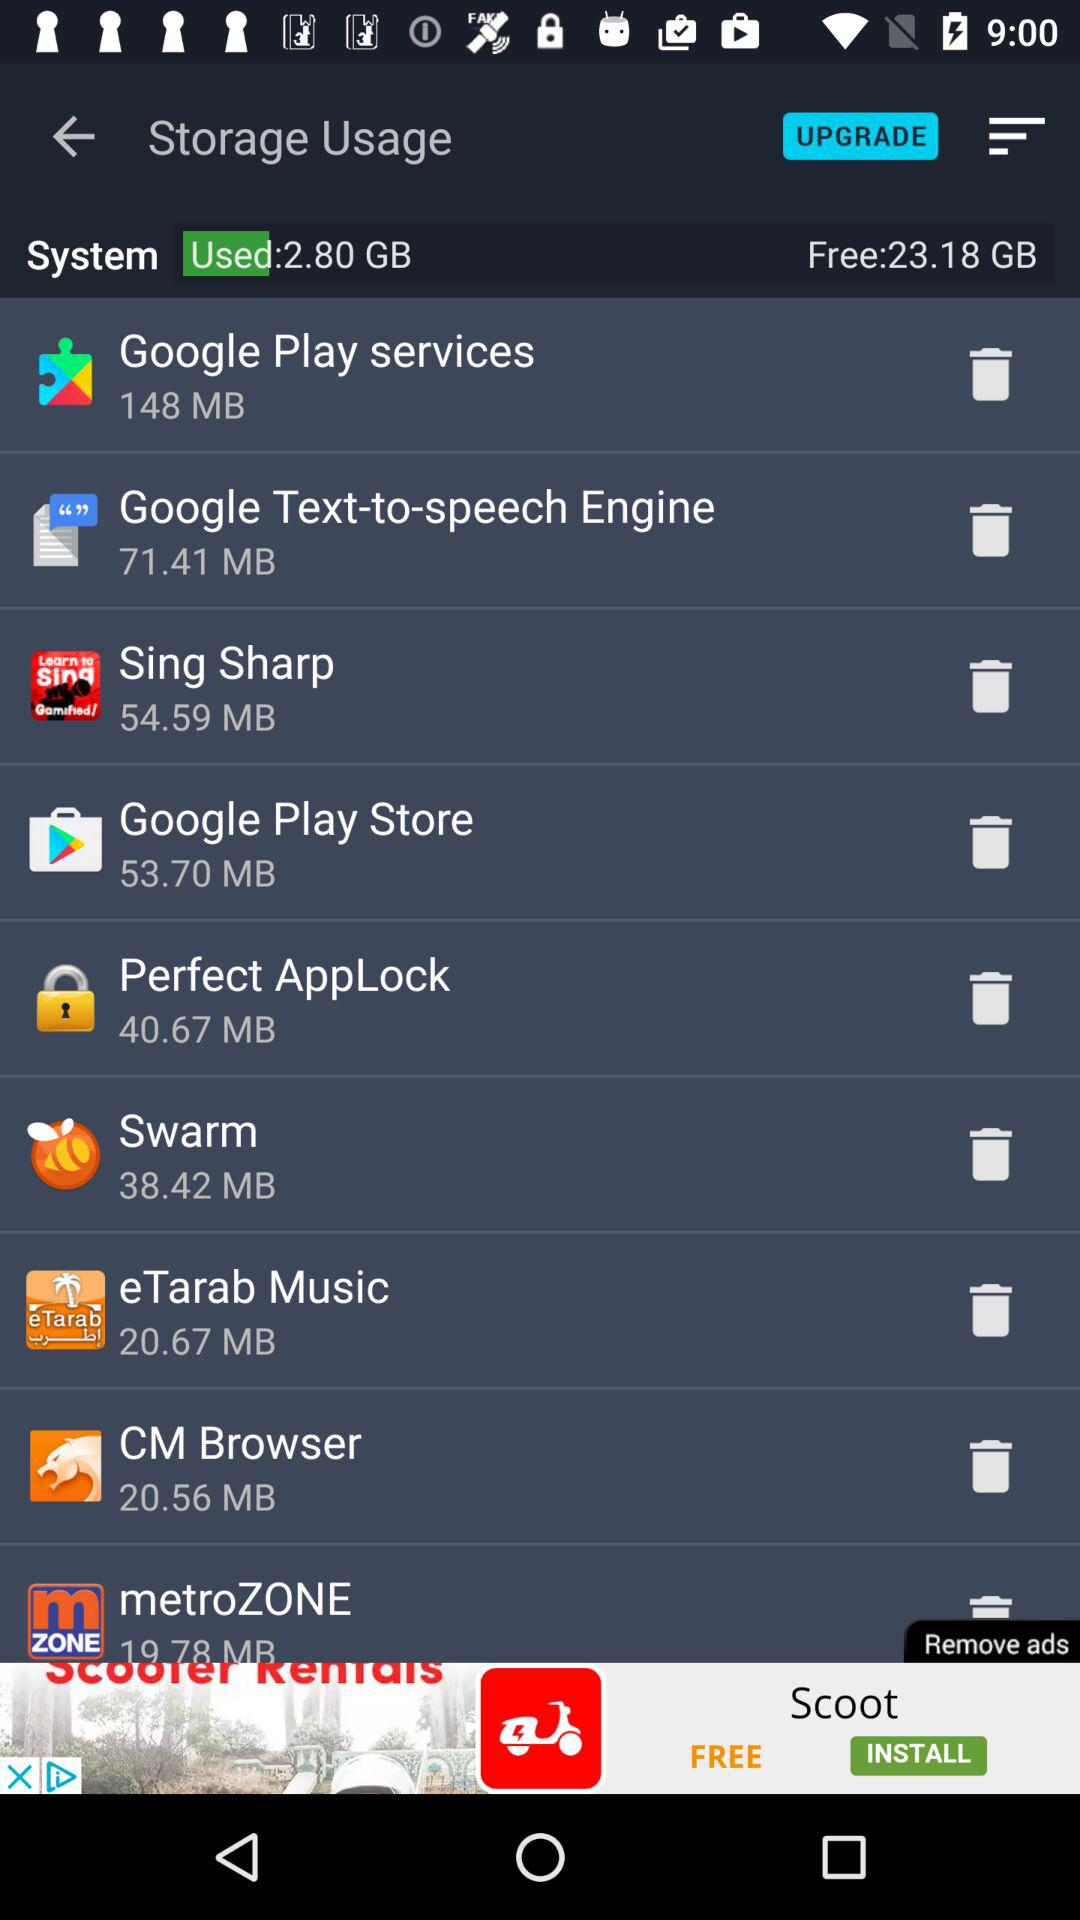What is the size of "Sing Sharp" in MB? The size of "Sing Sharp" is 54.59 MB. 